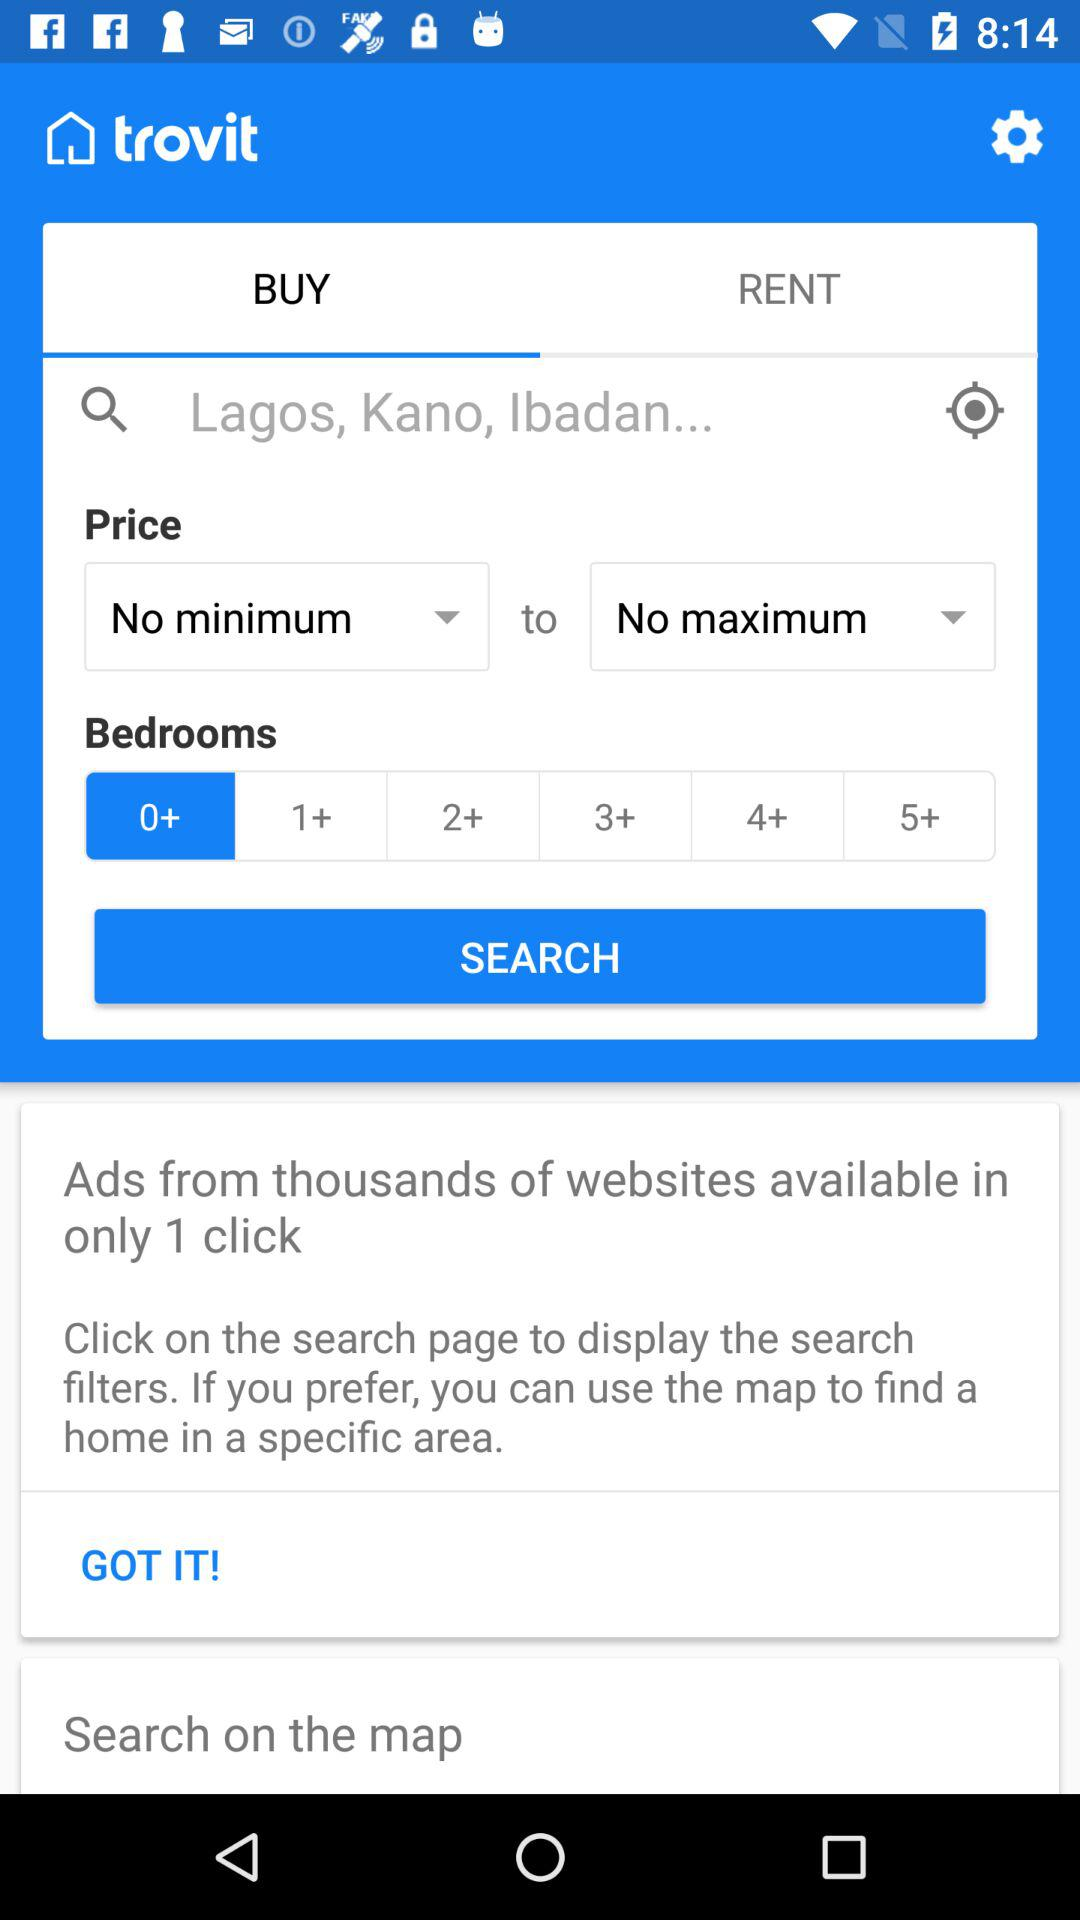Which tab is selected? The selected tab is "BUY". 